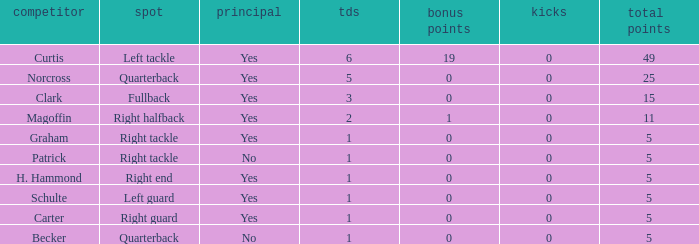Name the most field goals 0.0. 